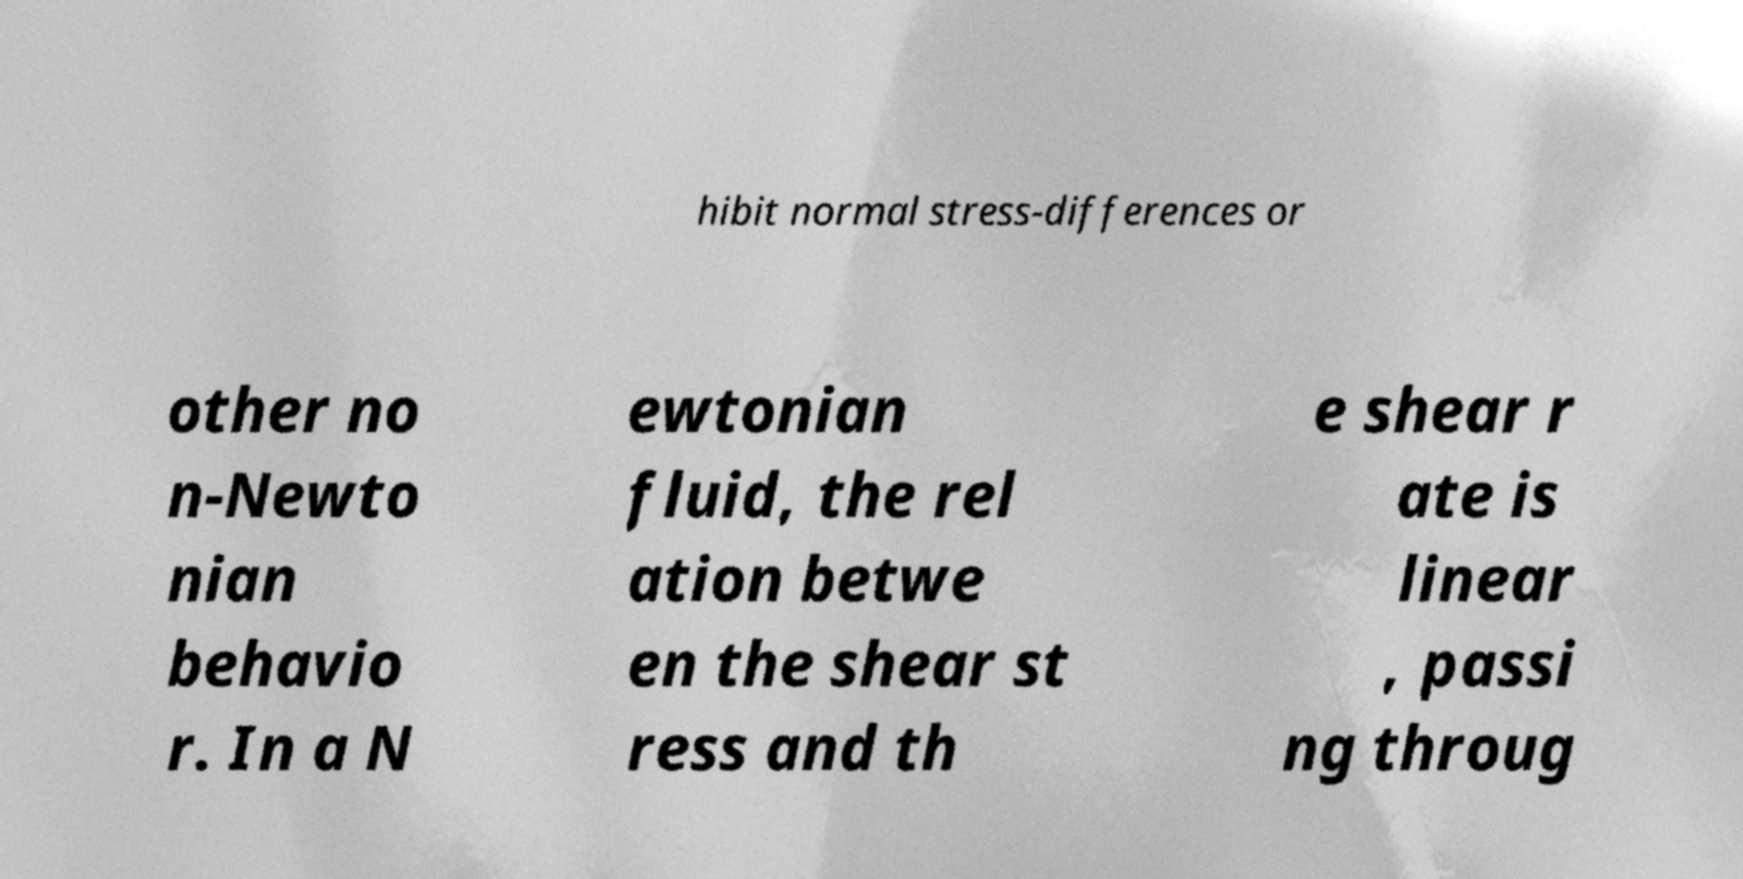Can you read and provide the text displayed in the image?This photo seems to have some interesting text. Can you extract and type it out for me? hibit normal stress-differences or other no n-Newto nian behavio r. In a N ewtonian fluid, the rel ation betwe en the shear st ress and th e shear r ate is linear , passi ng throug 